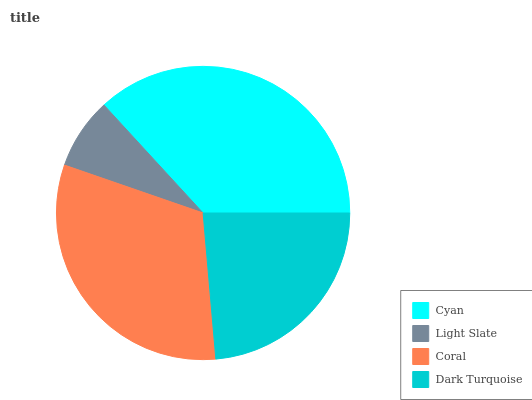Is Light Slate the minimum?
Answer yes or no. Yes. Is Cyan the maximum?
Answer yes or no. Yes. Is Coral the minimum?
Answer yes or no. No. Is Coral the maximum?
Answer yes or no. No. Is Coral greater than Light Slate?
Answer yes or no. Yes. Is Light Slate less than Coral?
Answer yes or no. Yes. Is Light Slate greater than Coral?
Answer yes or no. No. Is Coral less than Light Slate?
Answer yes or no. No. Is Coral the high median?
Answer yes or no. Yes. Is Dark Turquoise the low median?
Answer yes or no. Yes. Is Light Slate the high median?
Answer yes or no. No. Is Coral the low median?
Answer yes or no. No. 